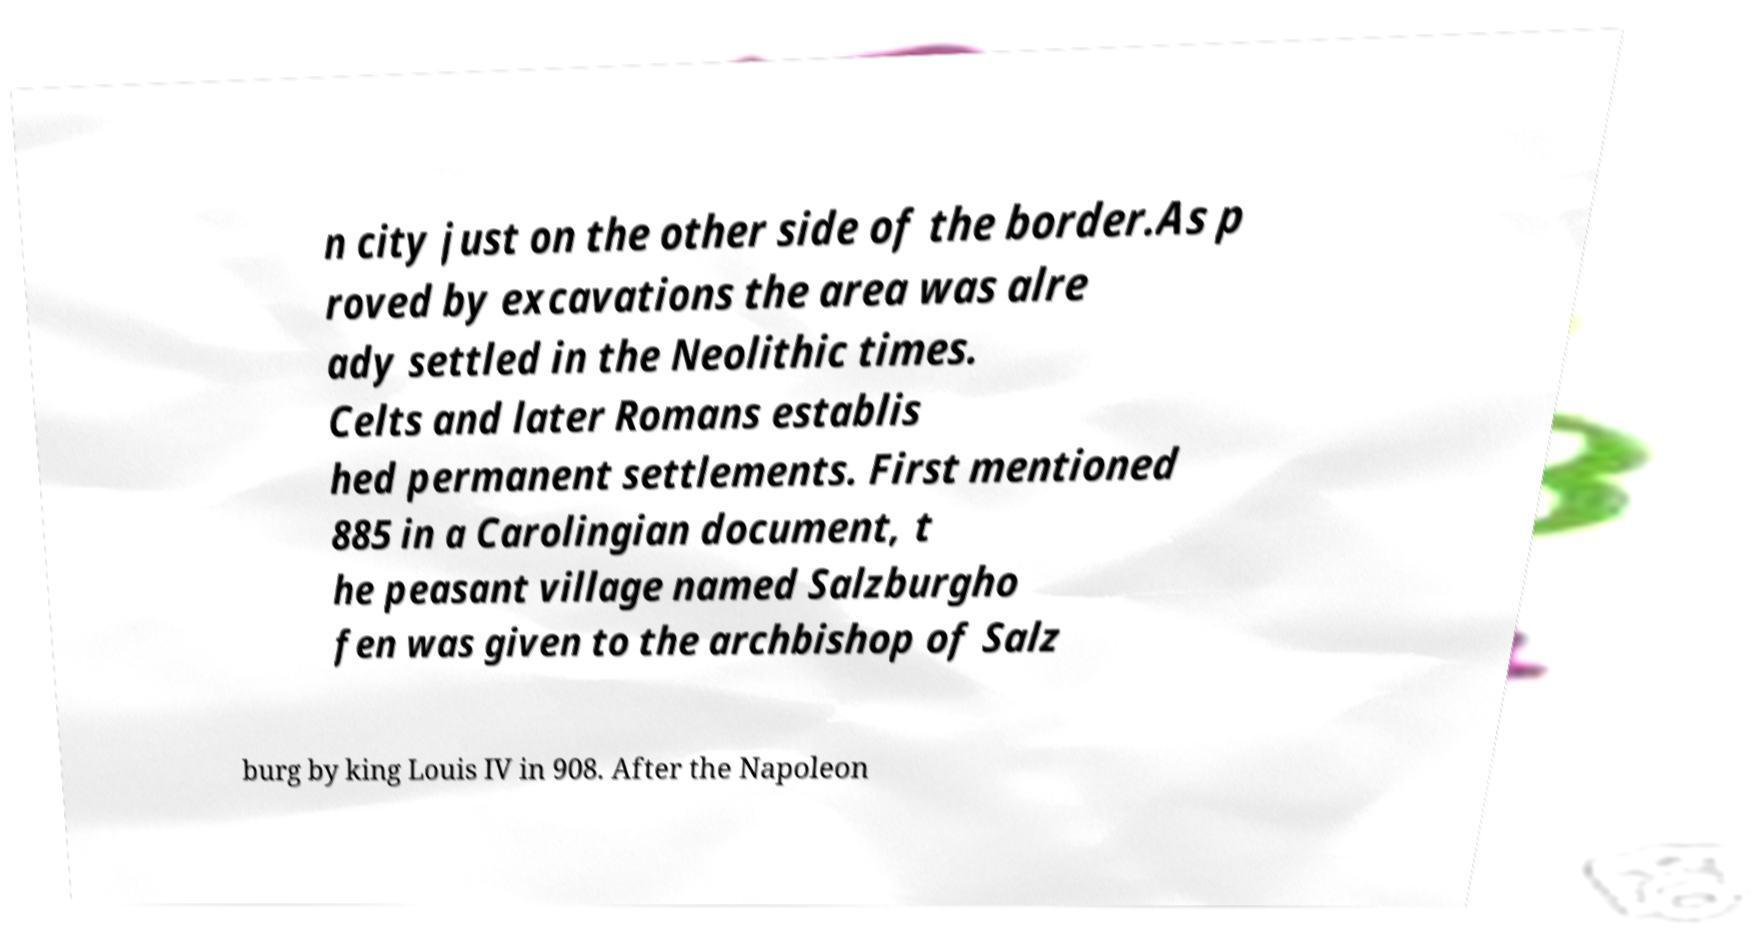Could you assist in decoding the text presented in this image and type it out clearly? n city just on the other side of the border.As p roved by excavations the area was alre ady settled in the Neolithic times. Celts and later Romans establis hed permanent settlements. First mentioned 885 in a Carolingian document, t he peasant village named Salzburgho fen was given to the archbishop of Salz burg by king Louis IV in 908. After the Napoleon 